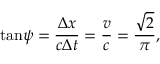<formula> <loc_0><loc_0><loc_500><loc_500>\tan \, \psi = \frac { \Delta x } { c \Delta t } = \frac { v } { c } = \frac { \sqrt { 2 } } { \pi } ,</formula> 